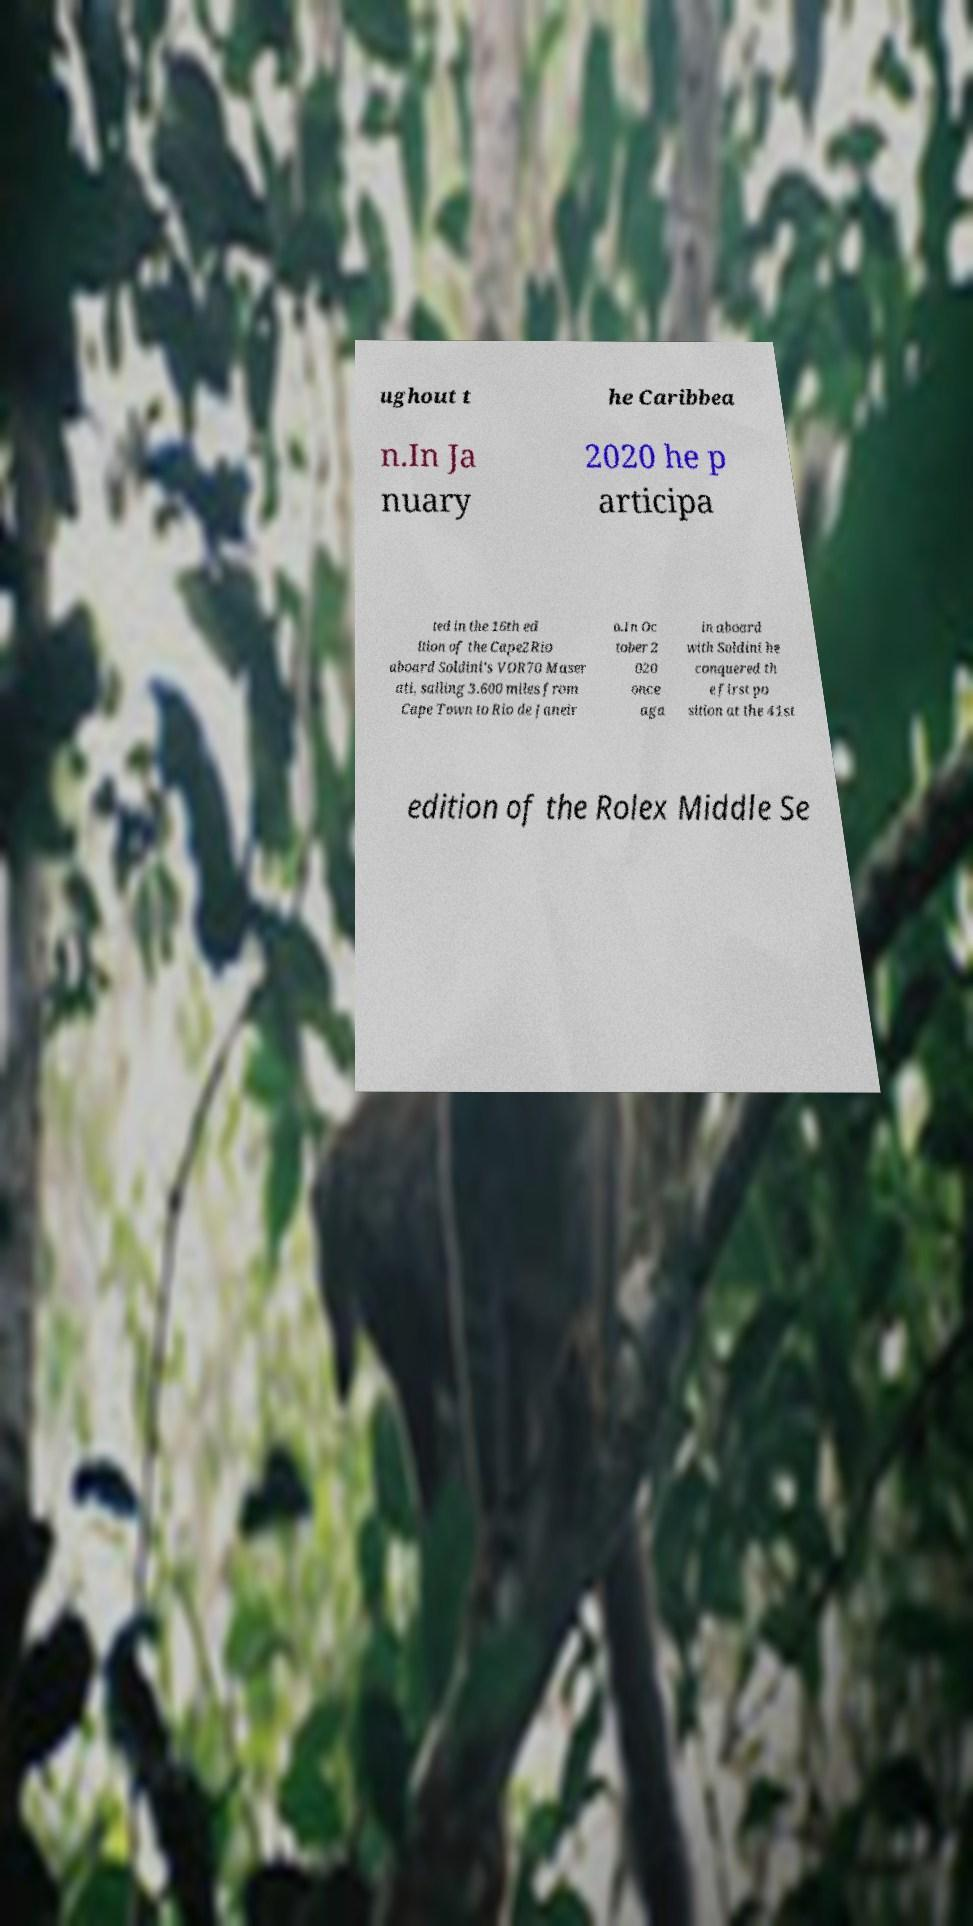Could you extract and type out the text from this image? ughout t he Caribbea n.In Ja nuary 2020 he p articipa ted in the 16th ed ition of the Cape2Rio aboard Soldini's VOR70 Maser ati, sailing 3.600 miles from Cape Town to Rio de Janeir o.In Oc tober 2 020 once aga in aboard with Soldini he conquered th e first po sition at the 41st edition of the Rolex Middle Se 